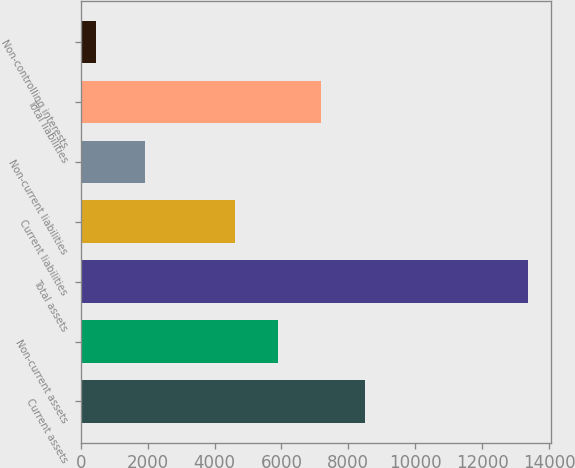<chart> <loc_0><loc_0><loc_500><loc_500><bar_chart><fcel>Current assets<fcel>Non-current assets<fcel>Total assets<fcel>Current liabilities<fcel>Non-current liabilities<fcel>Total liabilities<fcel>Non-controlling interests<nl><fcel>8507<fcel>5902.1<fcel>13381<fcel>4608<fcel>1905<fcel>7196.2<fcel>440<nl></chart> 